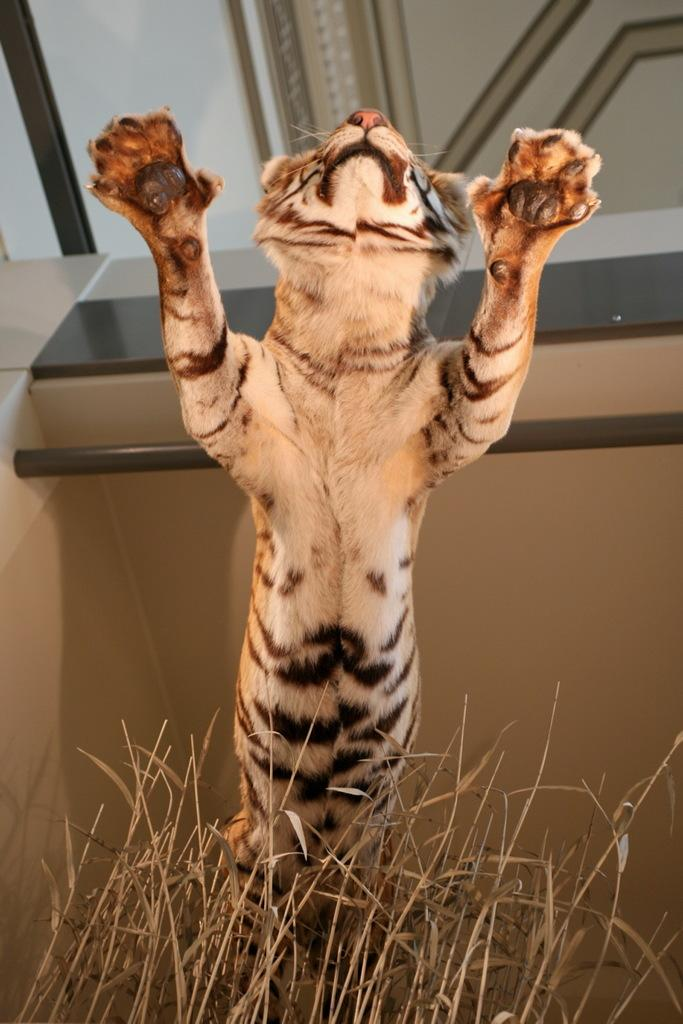What type of animal is present in the image? There is an animal in the image, but its specific type cannot be determined from the provided facts. What type of vegetation is visible in the image? There is grass visible in the image. What else can be seen in the background of the image? There are other objects in the background of the image, but their specific nature cannot be determined from the provided facts. How does the rat contribute to the reward system in the image? There is no rat present in the image, and therefore no such contribution can be observed. 